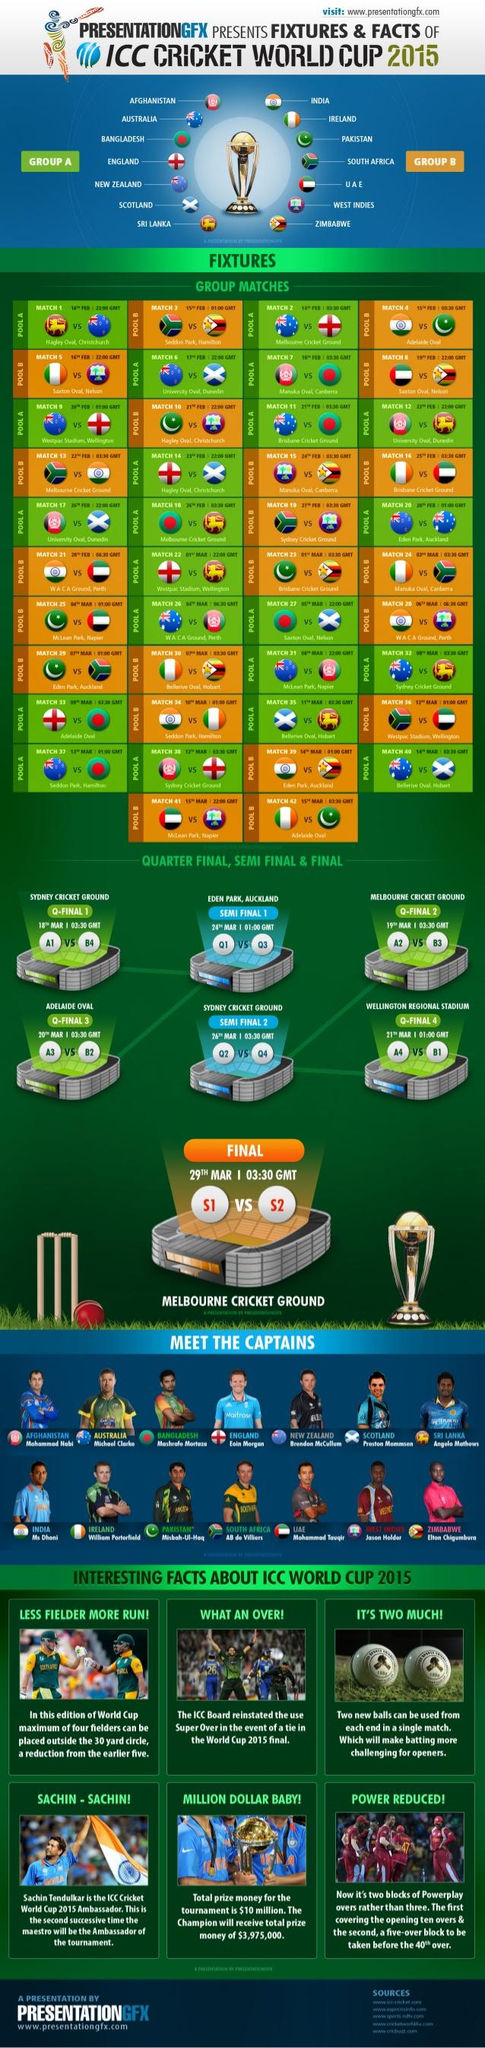Identify some key points in this picture. The Q-Final 1 match will take place on March 18th. In the 2015 Cricket World Cup, the number of fielders who were positioned outside the 30-yard circle during matches was reduced compared to the previous match. Specifically, there was a reduction of 1 fielder in this area. The match between India and Pakistan is scheduled for 15th February. Mahendra Singh Dhoni is the Indian captain. The countries that belong to Group B in Africa are South Africa, West Indies, and Zimbabwe. 